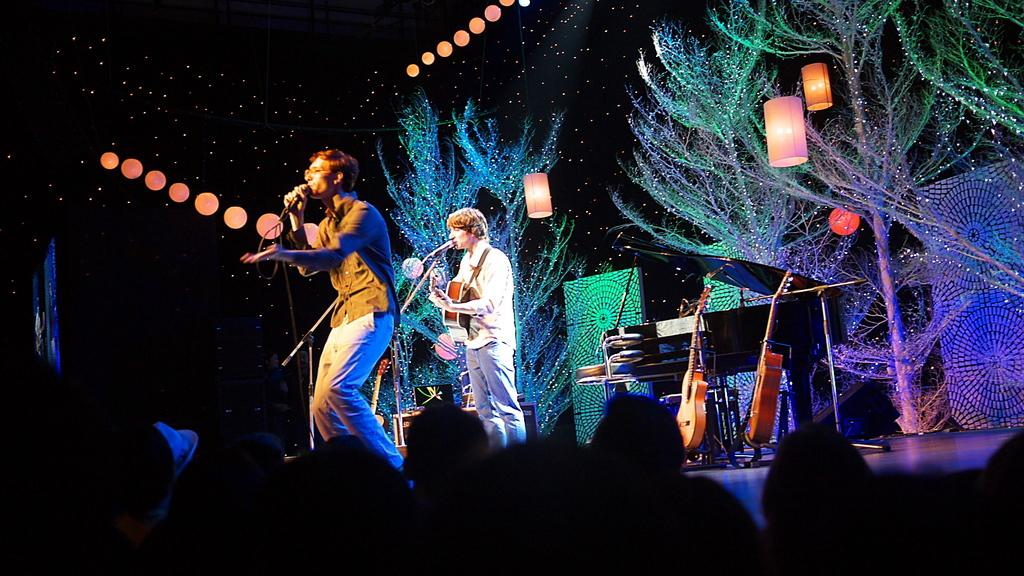What can be seen in the background of the image? There is a sky in the image. What else is visible in the image besides the sky? There are lights and trees in the image. What are the two people on stage doing? The two people on stage are singing. Are there any other people present in the image? Yes, there are people present in the image. What type of key is being used to ignite the flame on stage? There is no key or flame present in the image; it features a sky, lights, trees, and people on stage singing. 